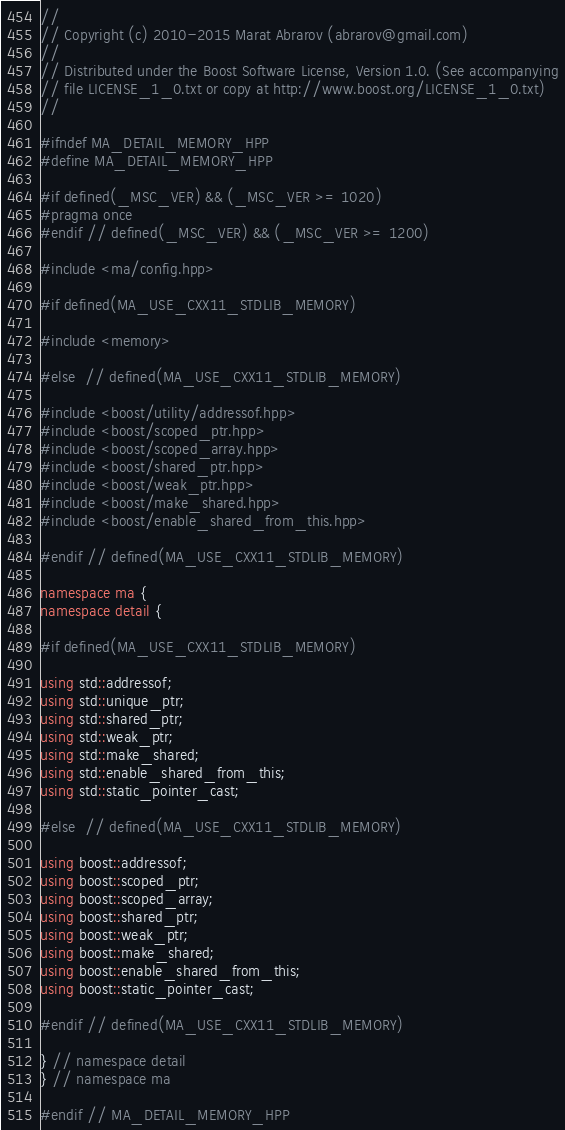<code> <loc_0><loc_0><loc_500><loc_500><_C++_>//
// Copyright (c) 2010-2015 Marat Abrarov (abrarov@gmail.com)
//
// Distributed under the Boost Software License, Version 1.0. (See accompanying
// file LICENSE_1_0.txt or copy at http://www.boost.org/LICENSE_1_0.txt)
//

#ifndef MA_DETAIL_MEMORY_HPP
#define MA_DETAIL_MEMORY_HPP

#if defined(_MSC_VER) && (_MSC_VER >= 1020)
#pragma once
#endif // defined(_MSC_VER) && (_MSC_VER >= 1200)

#include <ma/config.hpp>

#if defined(MA_USE_CXX11_STDLIB_MEMORY)

#include <memory>

#else  // defined(MA_USE_CXX11_STDLIB_MEMORY)

#include <boost/utility/addressof.hpp>
#include <boost/scoped_ptr.hpp>
#include <boost/scoped_array.hpp>
#include <boost/shared_ptr.hpp>
#include <boost/weak_ptr.hpp>
#include <boost/make_shared.hpp>
#include <boost/enable_shared_from_this.hpp>

#endif // defined(MA_USE_CXX11_STDLIB_MEMORY)

namespace ma {
namespace detail {

#if defined(MA_USE_CXX11_STDLIB_MEMORY)

using std::addressof;
using std::unique_ptr;
using std::shared_ptr;
using std::weak_ptr;
using std::make_shared;
using std::enable_shared_from_this;
using std::static_pointer_cast;

#else  // defined(MA_USE_CXX11_STDLIB_MEMORY)

using boost::addressof;
using boost::scoped_ptr;
using boost::scoped_array;
using boost::shared_ptr;
using boost::weak_ptr;
using boost::make_shared;
using boost::enable_shared_from_this;
using boost::static_pointer_cast;

#endif // defined(MA_USE_CXX11_STDLIB_MEMORY)

} // namespace detail
} // namespace ma

#endif // MA_DETAIL_MEMORY_HPP
</code> 